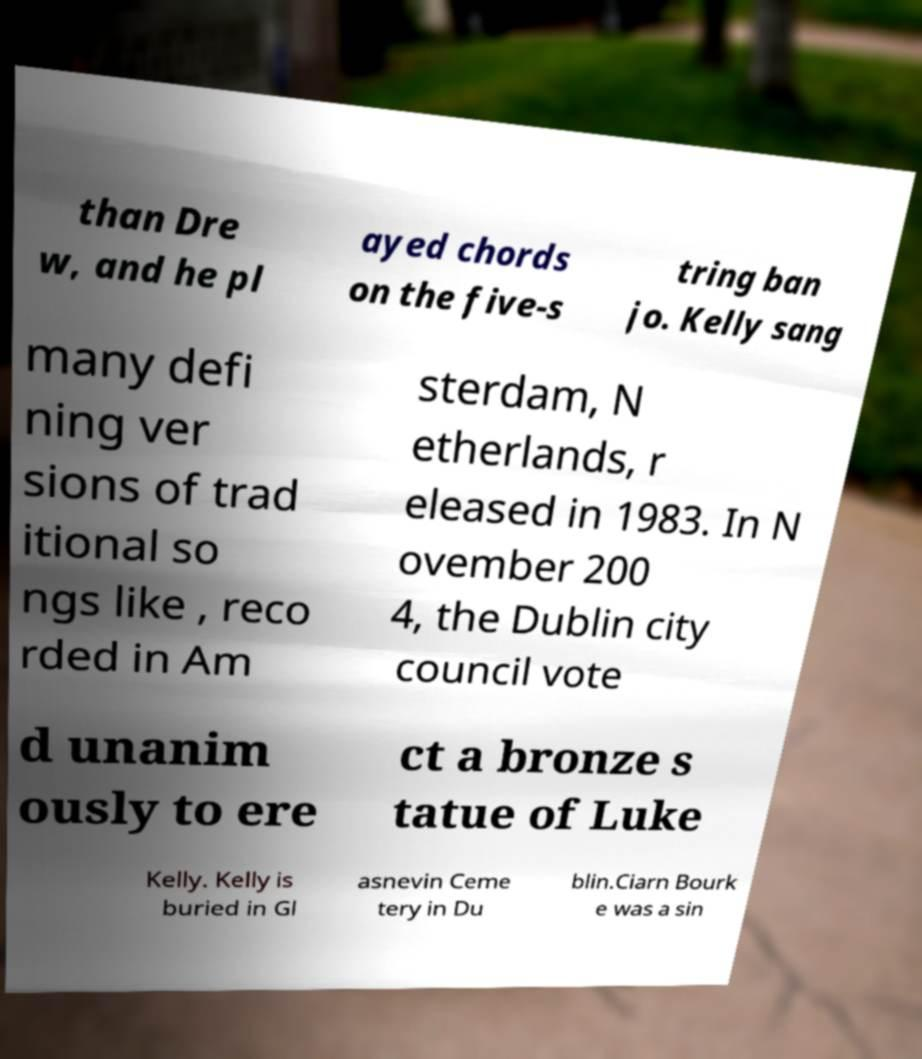What messages or text are displayed in this image? I need them in a readable, typed format. than Dre w, and he pl ayed chords on the five-s tring ban jo. Kelly sang many defi ning ver sions of trad itional so ngs like , reco rded in Am sterdam, N etherlands, r eleased in 1983. In N ovember 200 4, the Dublin city council vote d unanim ously to ere ct a bronze s tatue of Luke Kelly. Kelly is buried in Gl asnevin Ceme tery in Du blin.Ciarn Bourk e was a sin 